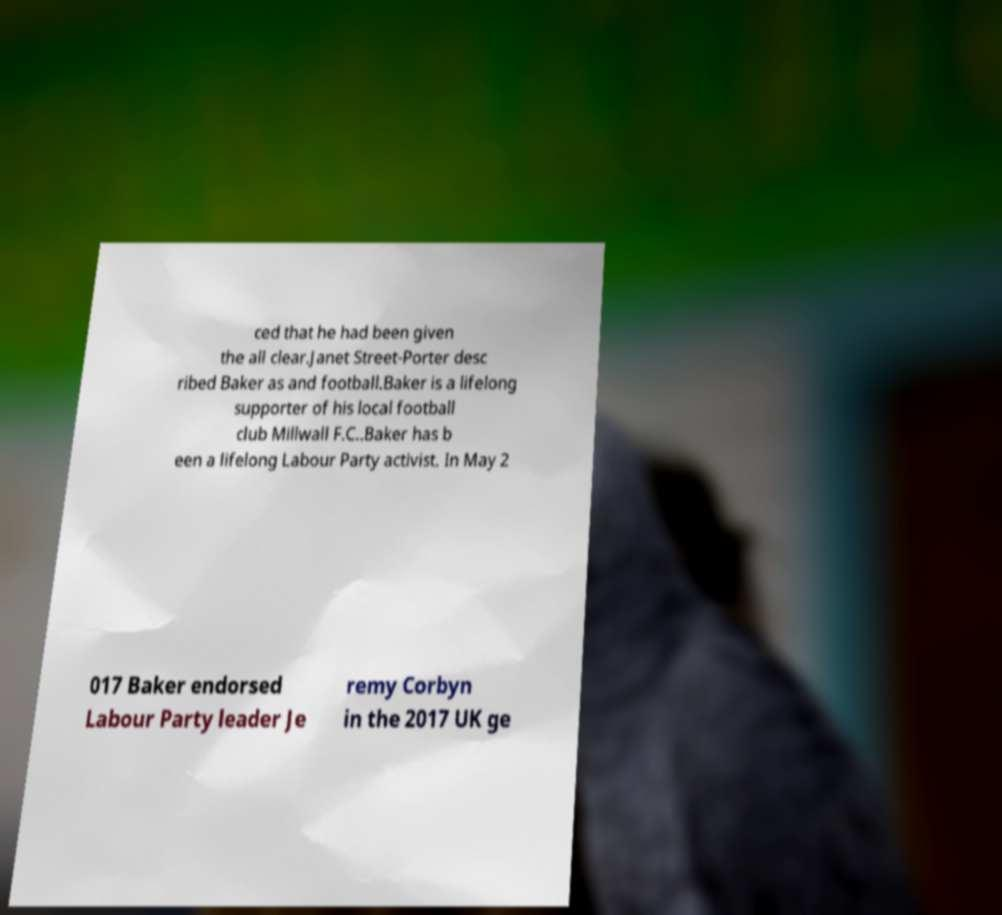Please read and relay the text visible in this image. What does it say? ced that he had been given the all clear.Janet Street-Porter desc ribed Baker as and football.Baker is a lifelong supporter of his local football club Millwall F.C..Baker has b een a lifelong Labour Party activist. In May 2 017 Baker endorsed Labour Party leader Je remy Corbyn in the 2017 UK ge 